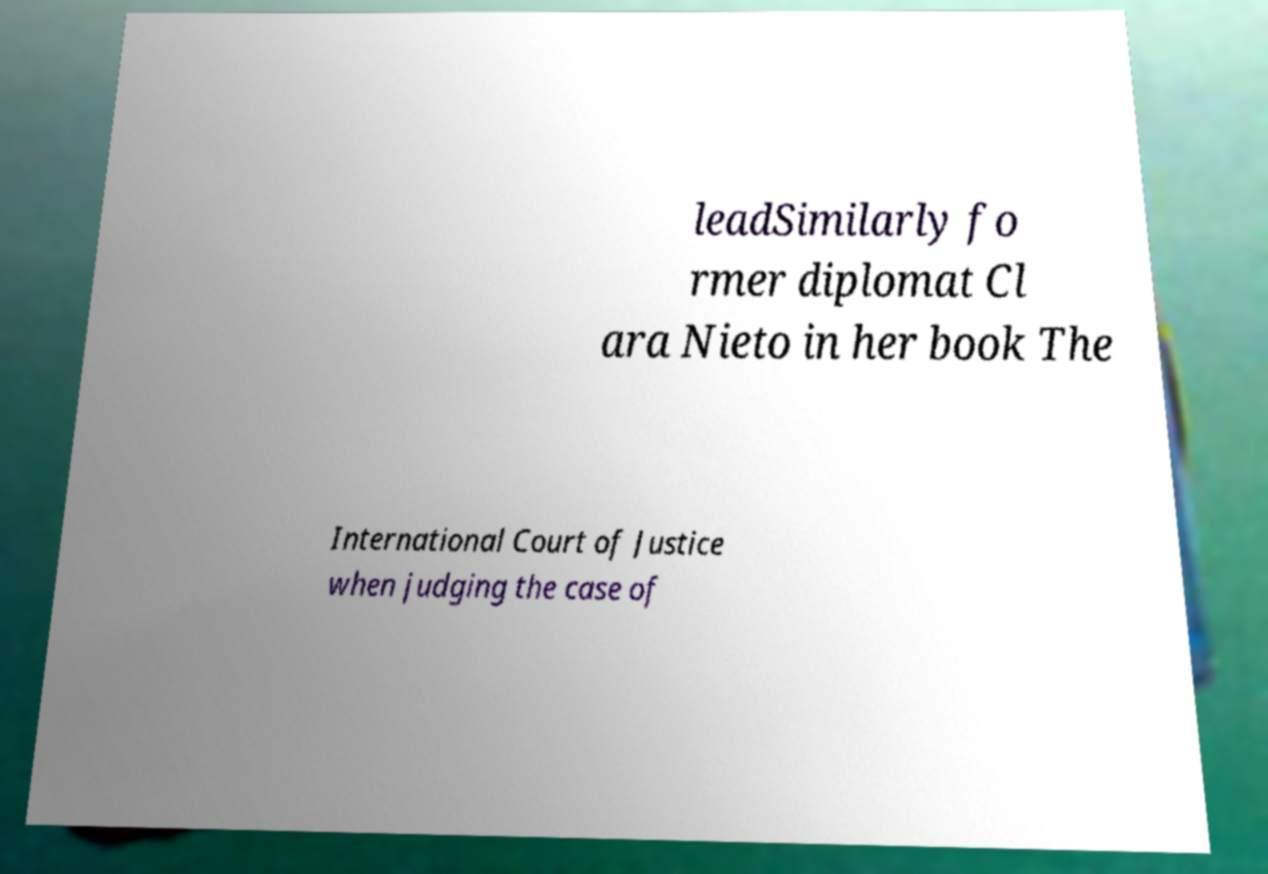For documentation purposes, I need the text within this image transcribed. Could you provide that? leadSimilarly fo rmer diplomat Cl ara Nieto in her book The International Court of Justice when judging the case of 